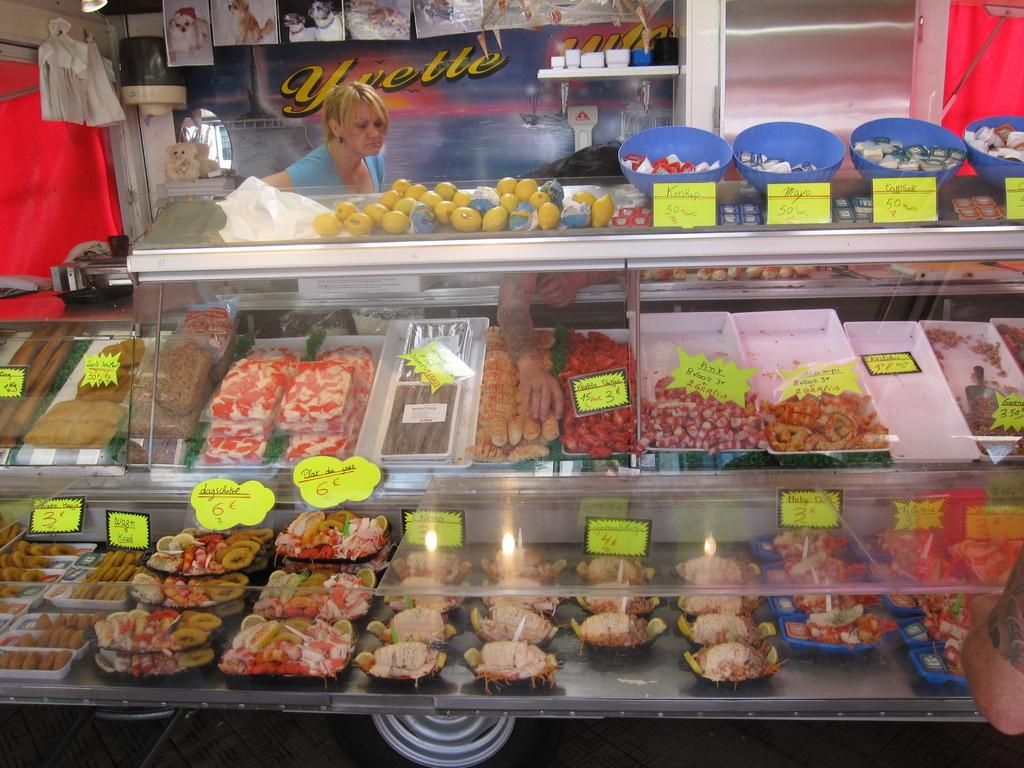<image>
Summarize the visual content of the image. food display with yellow pricing stickers some items labeled at 3, 6, 50 etc and poster in background with yvette on it 